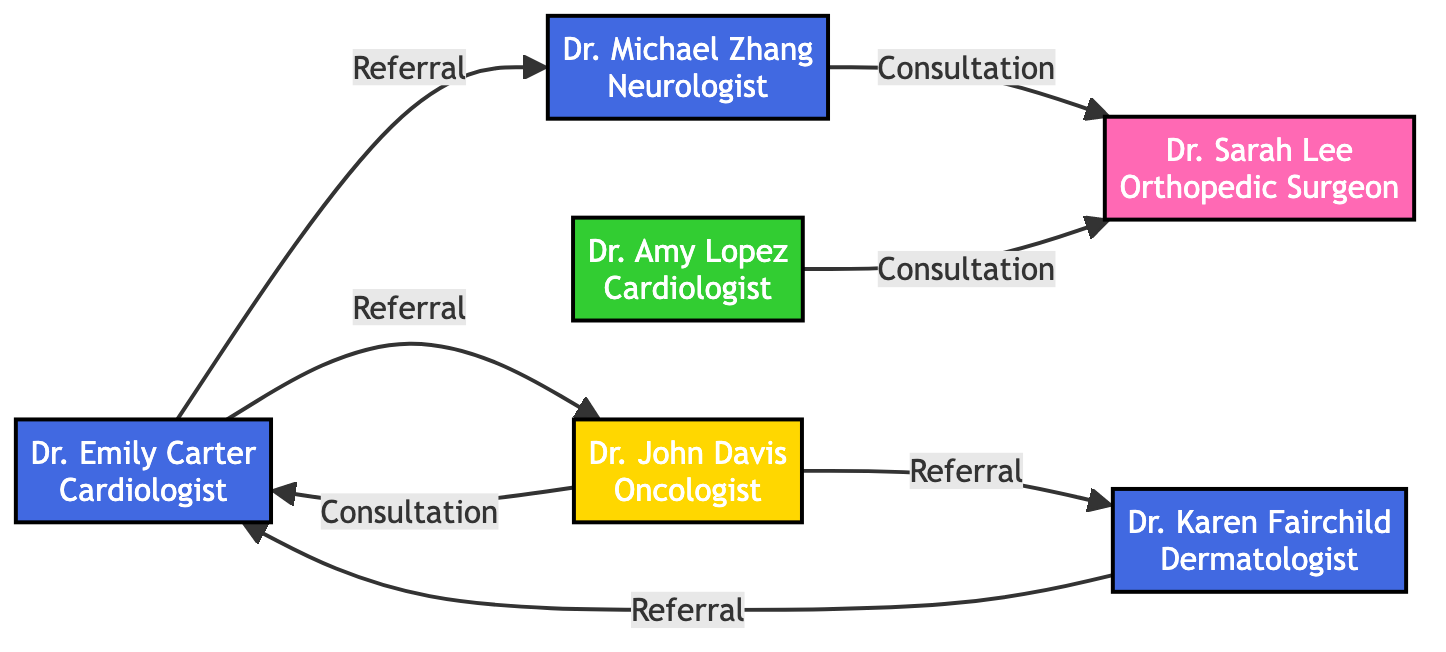What is the total number of specialists in the diagram? The diagram lists six specialists: Dr. Emily Carter, Dr. Michael Zhang, Dr. Sarah Lee, Dr. John Davis, Dr. Amy Lopez, and Dr. Karen Fairchild. Therefore, the total count is six.
Answer: 6 Which specialist has the most referrals in the diagram? Dr. Emily Carter refers to Dr. Michael Zhang, Dr. John Davis, and receives a referral from Dr. Karen Fairchild, making a total of three engagements. This is the highest among the specialists in the diagram.
Answer: Dr. Emily Carter What type of relationship exists between Dr. John Davis and Dr. Karen Fairchild? The relationship shows that Dr. John Davis refers patients to Dr. Karen Fairchild, indicating a 'Referral' type of connection.
Answer: Referral How many consultations does Dr. Sarah Lee participate in? Dr. Sarah Lee is involved in one consultation, which occurs when Dr. Michael Zhang refers a patient to her.
Answer: 1 Which specialists have consultations involving Dr. Sarah Lee? The diagram indicates that Dr. Sarah Lee has consultations only with Dr. Michael Zhang and Dr. Amy Lopez, as both refer patients to her for orthopedic care.
Answer: Dr. Michael Zhang, Dr. Amy Lopez Which specialist is affiliated with WakeMed Hospital? Among the specialists listed, only Dr. Amy Lopez is identified as being affiliated with WakeMed Hospital.
Answer: Dr. Amy Lopez Is there a direct referral from Dr. John Davis to Dr. Emily Carter? The diagram shows that Dr. John Davis does not have a direct referral to Dr. Emily Carter; instead, he has a consultation with her.
Answer: No What is the relationship between Dr. Emily Carter and Dr. John Davis? The connection between Dr. Emily Carter and Dr. John Davis is indicated as a 'Consultation', where they collaborate on patient care.
Answer: Consultation 